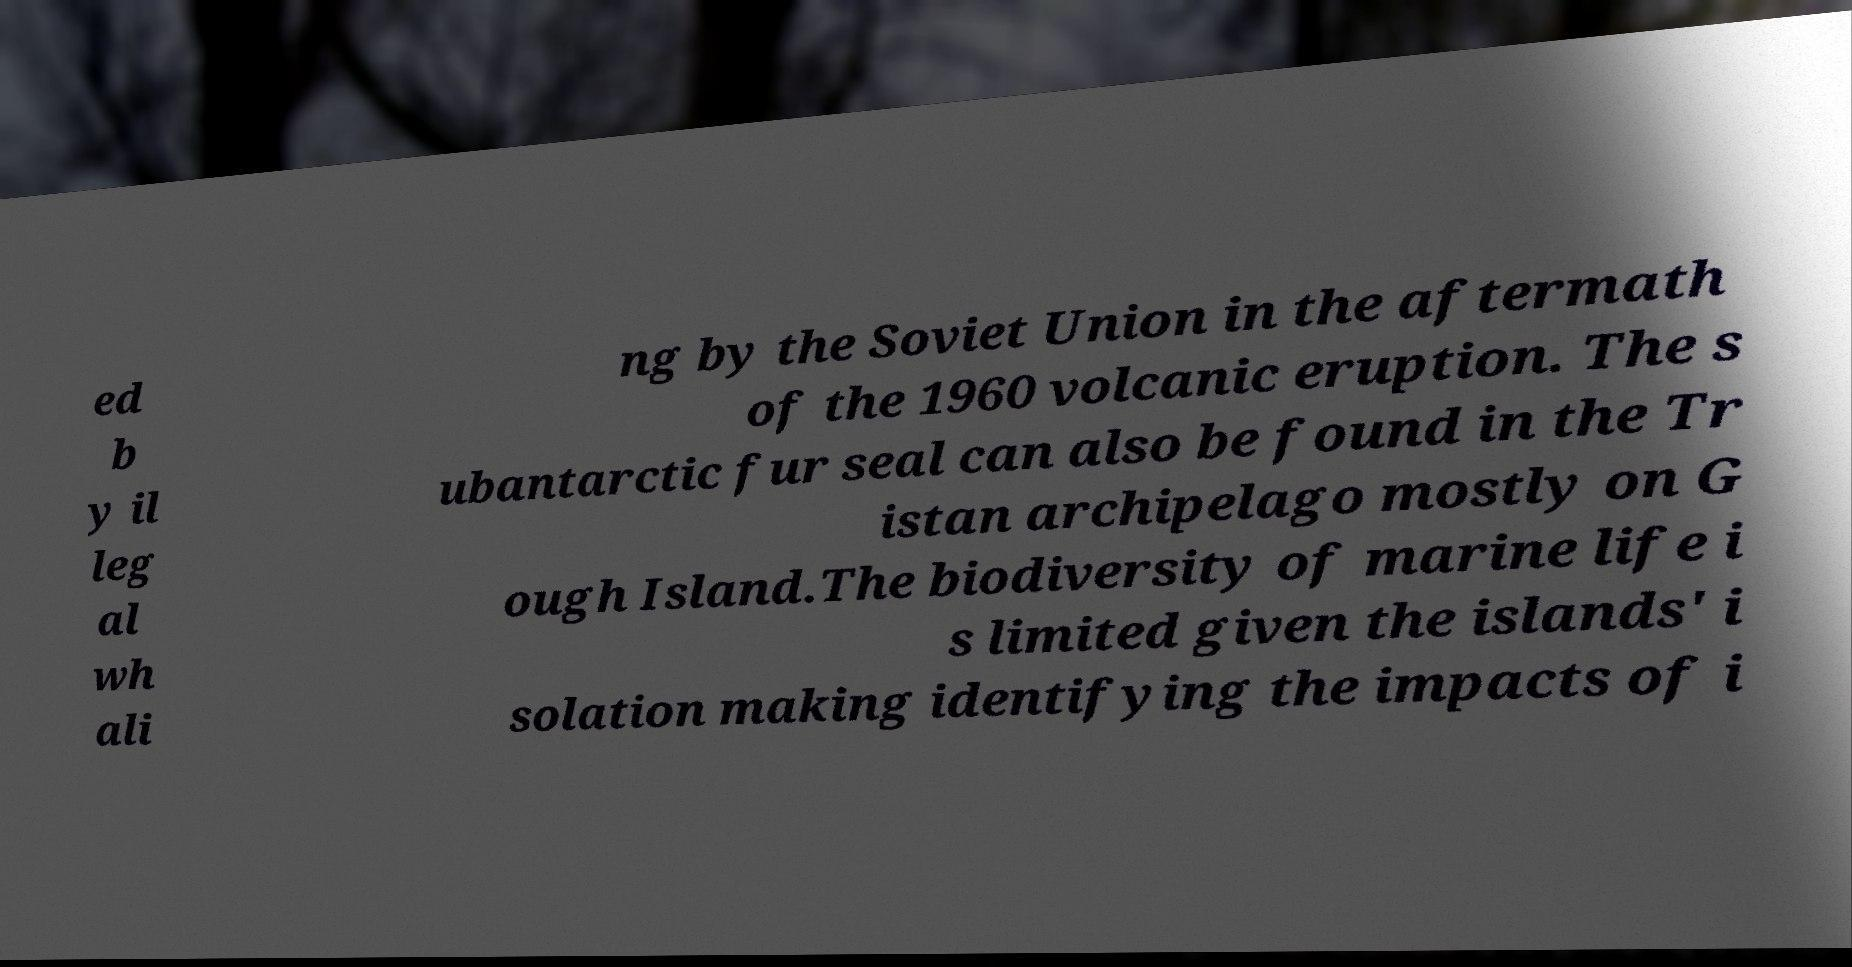What messages or text are displayed in this image? I need them in a readable, typed format. ed b y il leg al wh ali ng by the Soviet Union in the aftermath of the 1960 volcanic eruption. The s ubantarctic fur seal can also be found in the Tr istan archipelago mostly on G ough Island.The biodiversity of marine life i s limited given the islands' i solation making identifying the impacts of i 